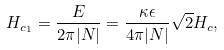<formula> <loc_0><loc_0><loc_500><loc_500>H _ { c _ { 1 } } = \frac { E } { 2 \pi | N | } = \frac { \kappa \epsilon } { 4 \pi | N | } \sqrt { 2 } H _ { c } ,</formula> 